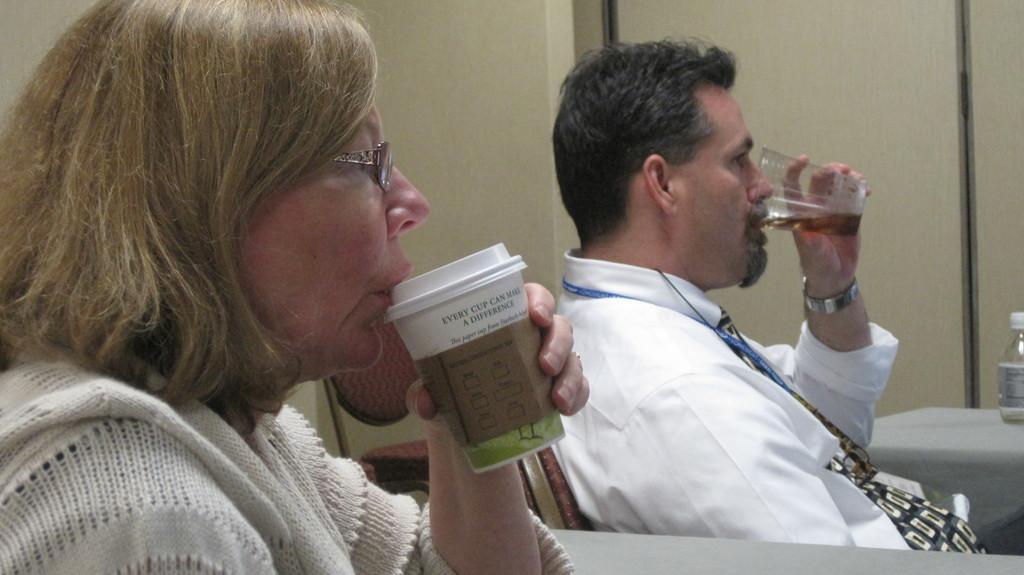Can you describe this image briefly? On the left side of the image a lady is sitting and holding a cup in her hand. In the center of the image a man is sitting on a chair and holding a glass in his hand. In the background of the image wall is there. On the right side of the image there is a table. On the table a bottle is there. 